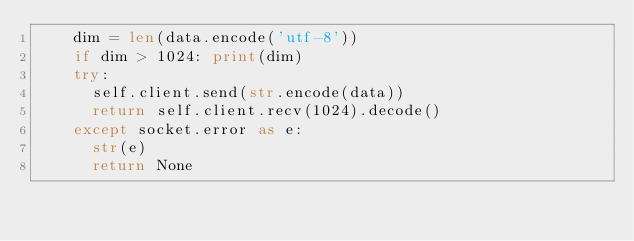Convert code to text. <code><loc_0><loc_0><loc_500><loc_500><_Python_>		dim = len(data.encode('utf-8'))
		if dim > 1024: print(dim)
		try:
			self.client.send(str.encode(data))
			return self.client.recv(1024).decode()
		except socket.error as e:
			str(e)
			return None</code> 